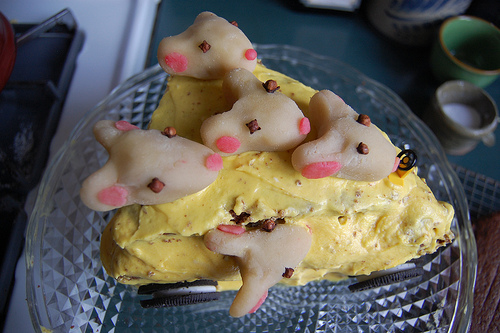<image>
Is the liquid in the cup? No. The liquid is not contained within the cup. These objects have a different spatial relationship. 